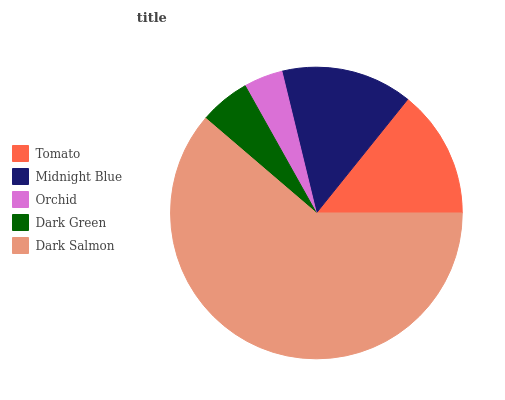Is Orchid the minimum?
Answer yes or no. Yes. Is Dark Salmon the maximum?
Answer yes or no. Yes. Is Midnight Blue the minimum?
Answer yes or no. No. Is Midnight Blue the maximum?
Answer yes or no. No. Is Midnight Blue greater than Tomato?
Answer yes or no. Yes. Is Tomato less than Midnight Blue?
Answer yes or no. Yes. Is Tomato greater than Midnight Blue?
Answer yes or no. No. Is Midnight Blue less than Tomato?
Answer yes or no. No. Is Tomato the high median?
Answer yes or no. Yes. Is Tomato the low median?
Answer yes or no. Yes. Is Dark Salmon the high median?
Answer yes or no. No. Is Dark Salmon the low median?
Answer yes or no. No. 